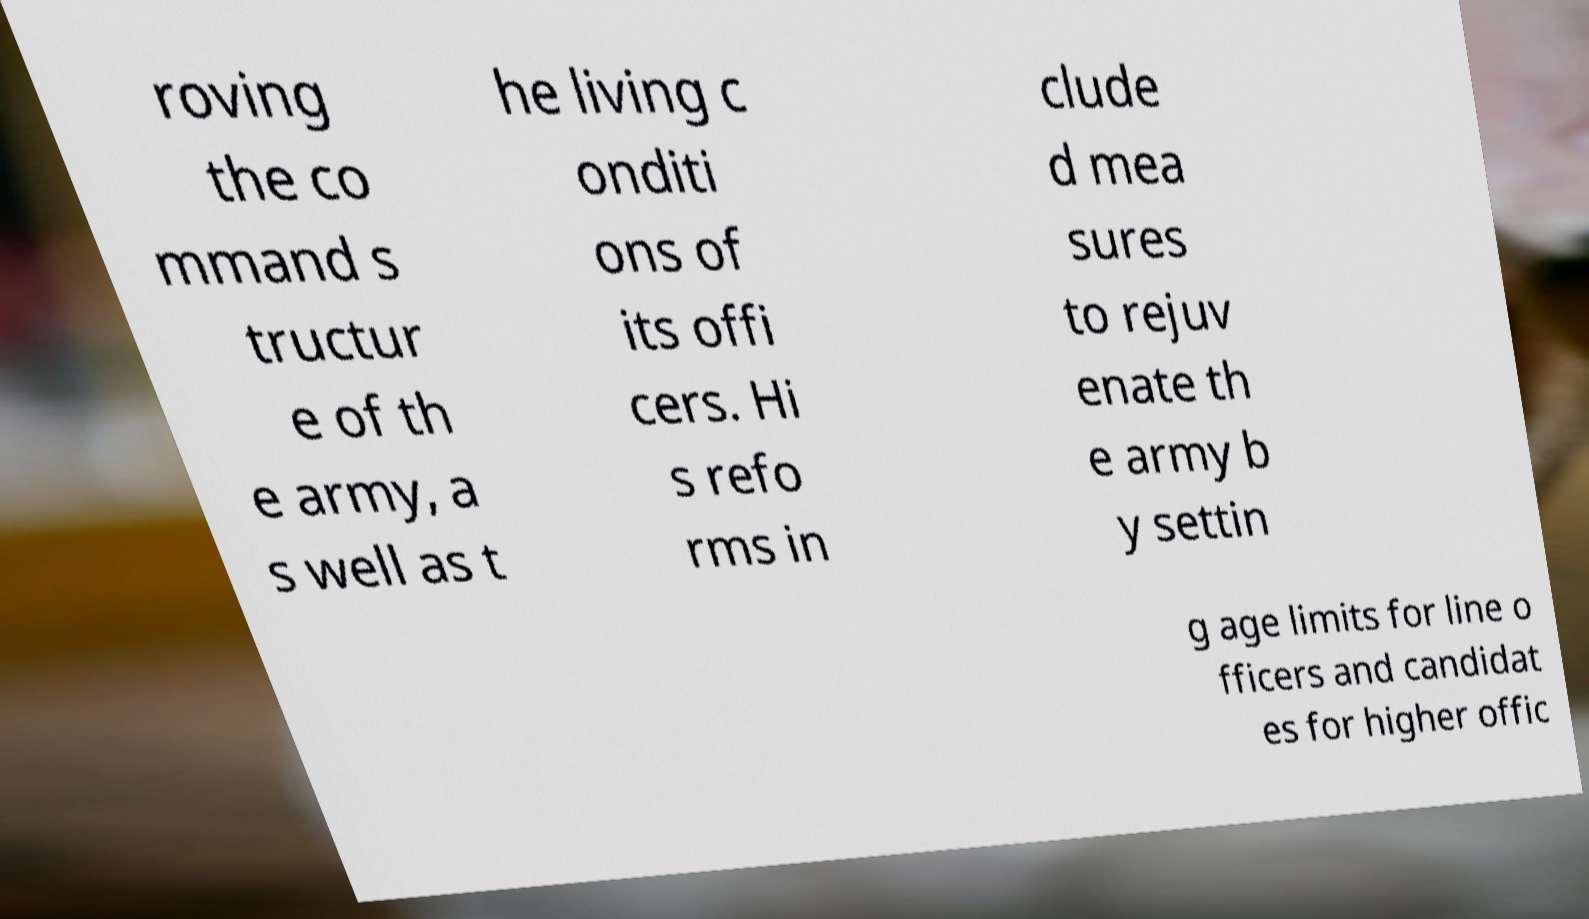Please read and relay the text visible in this image. What does it say? roving the co mmand s tructur e of th e army, a s well as t he living c onditi ons of its offi cers. Hi s refo rms in clude d mea sures to rejuv enate th e army b y settin g age limits for line o fficers and candidat es for higher offic 